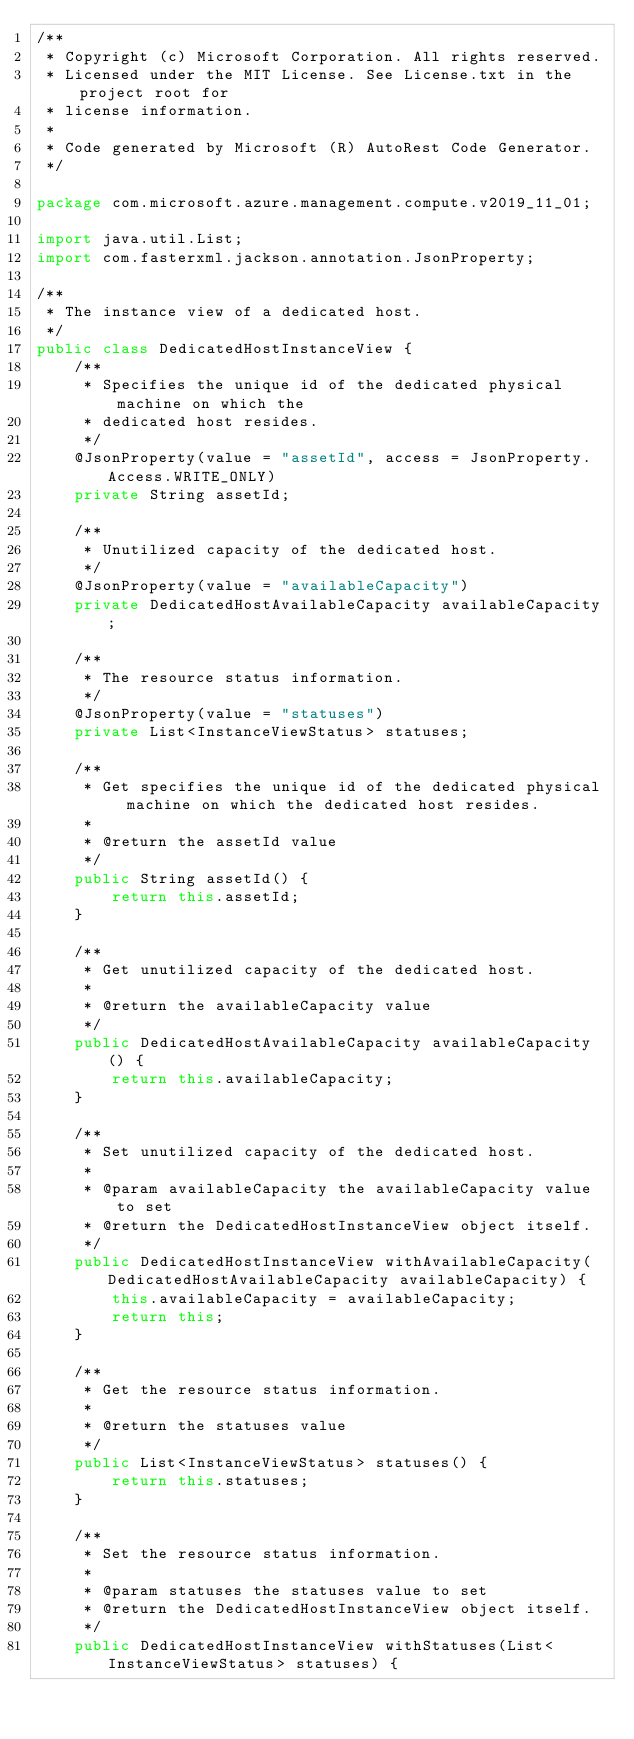<code> <loc_0><loc_0><loc_500><loc_500><_Java_>/**
 * Copyright (c) Microsoft Corporation. All rights reserved.
 * Licensed under the MIT License. See License.txt in the project root for
 * license information.
 *
 * Code generated by Microsoft (R) AutoRest Code Generator.
 */

package com.microsoft.azure.management.compute.v2019_11_01;

import java.util.List;
import com.fasterxml.jackson.annotation.JsonProperty;

/**
 * The instance view of a dedicated host.
 */
public class DedicatedHostInstanceView {
    /**
     * Specifies the unique id of the dedicated physical machine on which the
     * dedicated host resides.
     */
    @JsonProperty(value = "assetId", access = JsonProperty.Access.WRITE_ONLY)
    private String assetId;

    /**
     * Unutilized capacity of the dedicated host.
     */
    @JsonProperty(value = "availableCapacity")
    private DedicatedHostAvailableCapacity availableCapacity;

    /**
     * The resource status information.
     */
    @JsonProperty(value = "statuses")
    private List<InstanceViewStatus> statuses;

    /**
     * Get specifies the unique id of the dedicated physical machine on which the dedicated host resides.
     *
     * @return the assetId value
     */
    public String assetId() {
        return this.assetId;
    }

    /**
     * Get unutilized capacity of the dedicated host.
     *
     * @return the availableCapacity value
     */
    public DedicatedHostAvailableCapacity availableCapacity() {
        return this.availableCapacity;
    }

    /**
     * Set unutilized capacity of the dedicated host.
     *
     * @param availableCapacity the availableCapacity value to set
     * @return the DedicatedHostInstanceView object itself.
     */
    public DedicatedHostInstanceView withAvailableCapacity(DedicatedHostAvailableCapacity availableCapacity) {
        this.availableCapacity = availableCapacity;
        return this;
    }

    /**
     * Get the resource status information.
     *
     * @return the statuses value
     */
    public List<InstanceViewStatus> statuses() {
        return this.statuses;
    }

    /**
     * Set the resource status information.
     *
     * @param statuses the statuses value to set
     * @return the DedicatedHostInstanceView object itself.
     */
    public DedicatedHostInstanceView withStatuses(List<InstanceViewStatus> statuses) {</code> 